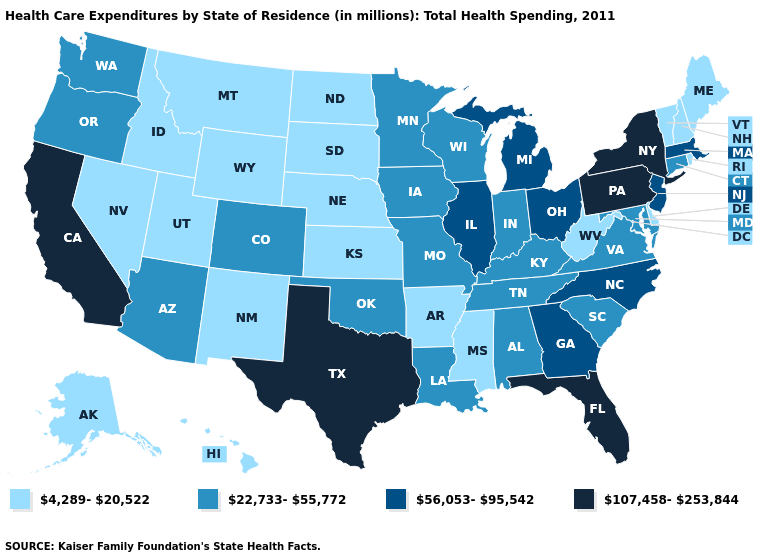What is the value of Idaho?
Keep it brief. 4,289-20,522. Name the states that have a value in the range 107,458-253,844?
Write a very short answer. California, Florida, New York, Pennsylvania, Texas. Name the states that have a value in the range 22,733-55,772?
Quick response, please. Alabama, Arizona, Colorado, Connecticut, Indiana, Iowa, Kentucky, Louisiana, Maryland, Minnesota, Missouri, Oklahoma, Oregon, South Carolina, Tennessee, Virginia, Washington, Wisconsin. Name the states that have a value in the range 56,053-95,542?
Short answer required. Georgia, Illinois, Massachusetts, Michigan, New Jersey, North Carolina, Ohio. Which states have the highest value in the USA?
Quick response, please. California, Florida, New York, Pennsylvania, Texas. Name the states that have a value in the range 107,458-253,844?
Write a very short answer. California, Florida, New York, Pennsylvania, Texas. What is the highest value in the USA?
Give a very brief answer. 107,458-253,844. Among the states that border Mississippi , does Louisiana have the lowest value?
Write a very short answer. No. What is the lowest value in states that border Louisiana?
Answer briefly. 4,289-20,522. What is the highest value in states that border Maryland?
Answer briefly. 107,458-253,844. What is the value of Louisiana?
Quick response, please. 22,733-55,772. Does Illinois have a lower value than Montana?
Quick response, please. No. Name the states that have a value in the range 4,289-20,522?
Write a very short answer. Alaska, Arkansas, Delaware, Hawaii, Idaho, Kansas, Maine, Mississippi, Montana, Nebraska, Nevada, New Hampshire, New Mexico, North Dakota, Rhode Island, South Dakota, Utah, Vermont, West Virginia, Wyoming. Among the states that border California , does Oregon have the highest value?
Concise answer only. Yes. What is the lowest value in the USA?
Short answer required. 4,289-20,522. 